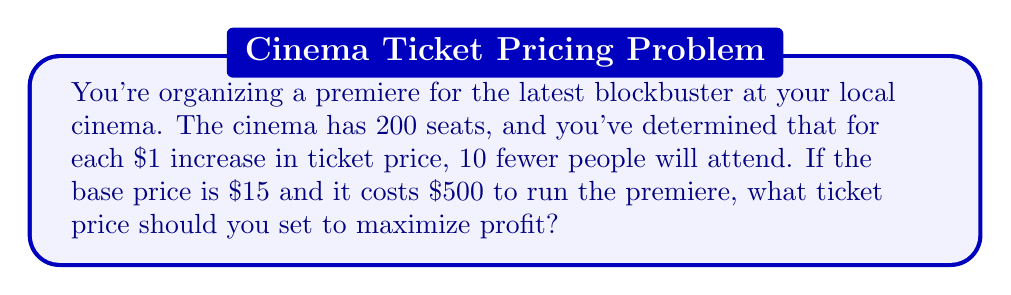Solve this math problem. Let's approach this step-by-step:

1) Let $x$ be the increase in price from the base price of $15.
   So, the ticket price will be $(15 + x)$.

2) The number of attendees will be $200 - 10x$.

3) The revenue function $R(x)$ is:
   $R(x) = (15 + x)(200 - 10x)$

4) Expand this:
   $R(x) = 3000 + 200x - 150x - 10x^2 = 3000 + 50x - 10x^2$

5) The profit function $P(x)$ is revenue minus costs:
   $P(x) = R(x) - 500 = 2500 + 50x - 10x^2$

6) To find the maximum profit, we need to find where $\frac{dP}{dx} = 0$:
   $\frac{dP}{dx} = 50 - 20x$

7) Set this equal to zero and solve:
   $50 - 20x = 0$
   $-20x = -50$
   $x = 2.5$

8) The second derivative $\frac{d^2P}{dx^2} = -20$ is negative, confirming this is a maximum.

9) Therefore, the optimal price increase is $2.50.

10) The optimal ticket price is $15 + $2.50 = $17.50.
Answer: $17.50 